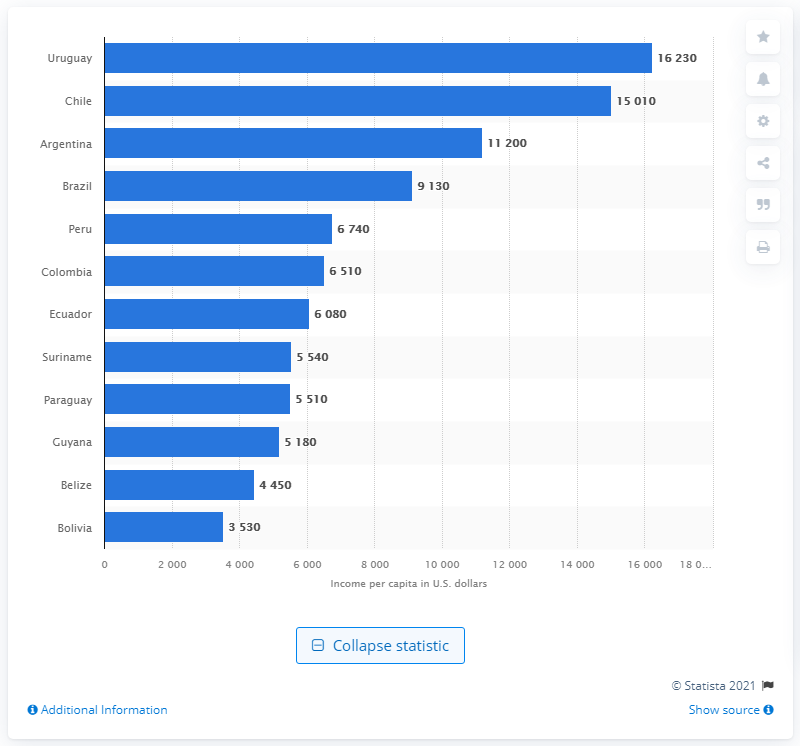Mention a couple of crucial points in this snapshot. Uruguay had the highest average income per capita among all the countries. According to available data, the gross national income per person in Chile in 1501 was approximately 15010. In 1623, Uruguay's per capita income was estimated to be approximately $16,230. 